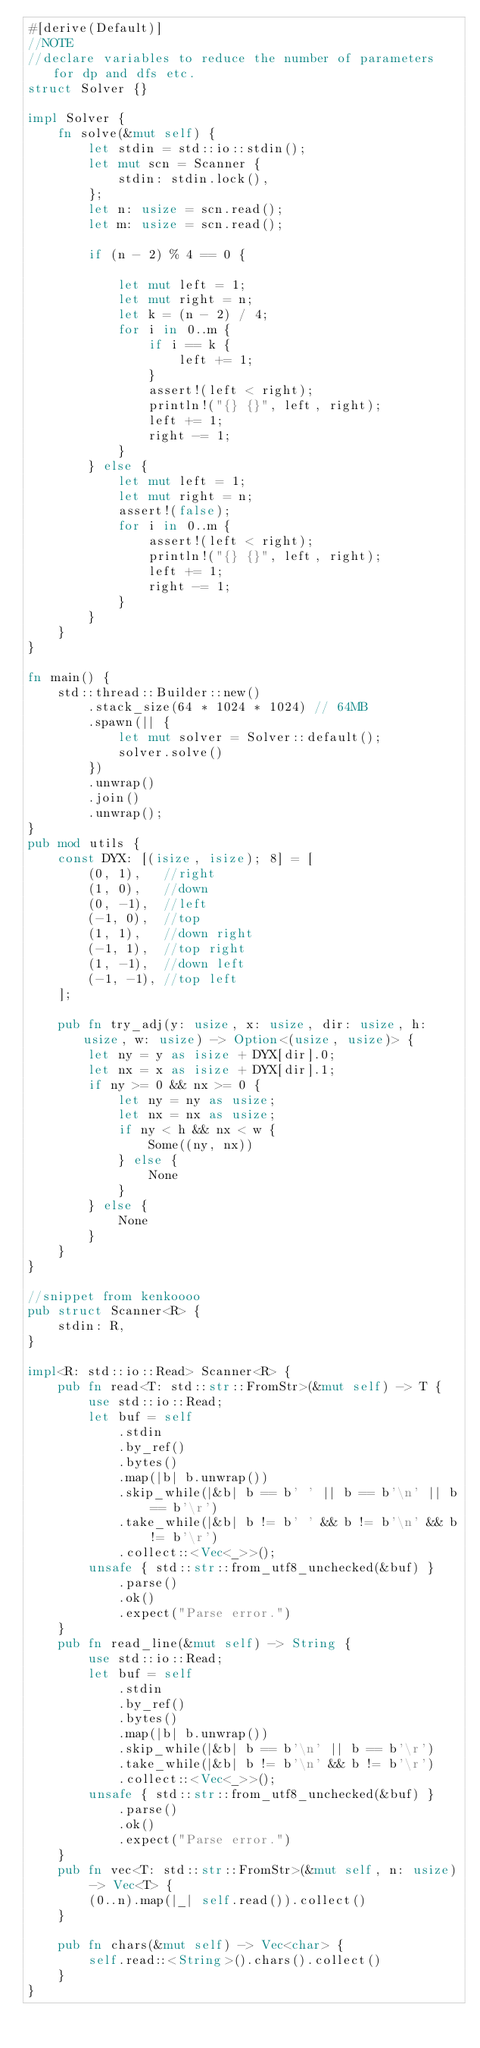Convert code to text. <code><loc_0><loc_0><loc_500><loc_500><_Rust_>#[derive(Default)]
//NOTE
//declare variables to reduce the number of parameters for dp and dfs etc.
struct Solver {}

impl Solver {
    fn solve(&mut self) {
        let stdin = std::io::stdin();
        let mut scn = Scanner {
            stdin: stdin.lock(),
        };
        let n: usize = scn.read();
        let m: usize = scn.read();

        if (n - 2) % 4 == 0 {

            let mut left = 1;
            let mut right = n;
            let k = (n - 2) / 4;
            for i in 0..m {
                if i == k {
                    left += 1;
                }
                assert!(left < right);
                println!("{} {}", left, right);
                left += 1;
                right -= 1;
            }
        } else {
            let mut left = 1;
            let mut right = n;
            assert!(false);
            for i in 0..m {
                assert!(left < right);
                println!("{} {}", left, right);
                left += 1;
                right -= 1;
            }
        }
    }
}

fn main() {
    std::thread::Builder::new()
        .stack_size(64 * 1024 * 1024) // 64MB
        .spawn(|| {
            let mut solver = Solver::default();
            solver.solve()
        })
        .unwrap()
        .join()
        .unwrap();
}
pub mod utils {
    const DYX: [(isize, isize); 8] = [
        (0, 1),   //right
        (1, 0),   //down
        (0, -1),  //left
        (-1, 0),  //top
        (1, 1),   //down right
        (-1, 1),  //top right
        (1, -1),  //down left
        (-1, -1), //top left
    ];

    pub fn try_adj(y: usize, x: usize, dir: usize, h: usize, w: usize) -> Option<(usize, usize)> {
        let ny = y as isize + DYX[dir].0;
        let nx = x as isize + DYX[dir].1;
        if ny >= 0 && nx >= 0 {
            let ny = ny as usize;
            let nx = nx as usize;
            if ny < h && nx < w {
                Some((ny, nx))
            } else {
                None
            }
        } else {
            None
        }
    }
}

//snippet from kenkoooo
pub struct Scanner<R> {
    stdin: R,
}

impl<R: std::io::Read> Scanner<R> {
    pub fn read<T: std::str::FromStr>(&mut self) -> T {
        use std::io::Read;
        let buf = self
            .stdin
            .by_ref()
            .bytes()
            .map(|b| b.unwrap())
            .skip_while(|&b| b == b' ' || b == b'\n' || b == b'\r')
            .take_while(|&b| b != b' ' && b != b'\n' && b != b'\r')
            .collect::<Vec<_>>();
        unsafe { std::str::from_utf8_unchecked(&buf) }
            .parse()
            .ok()
            .expect("Parse error.")
    }
    pub fn read_line(&mut self) -> String {
        use std::io::Read;
        let buf = self
            .stdin
            .by_ref()
            .bytes()
            .map(|b| b.unwrap())
            .skip_while(|&b| b == b'\n' || b == b'\r')
            .take_while(|&b| b != b'\n' && b != b'\r')
            .collect::<Vec<_>>();
        unsafe { std::str::from_utf8_unchecked(&buf) }
            .parse()
            .ok()
            .expect("Parse error.")
    }
    pub fn vec<T: std::str::FromStr>(&mut self, n: usize) -> Vec<T> {
        (0..n).map(|_| self.read()).collect()
    }

    pub fn chars(&mut self) -> Vec<char> {
        self.read::<String>().chars().collect()
    }
}
</code> 